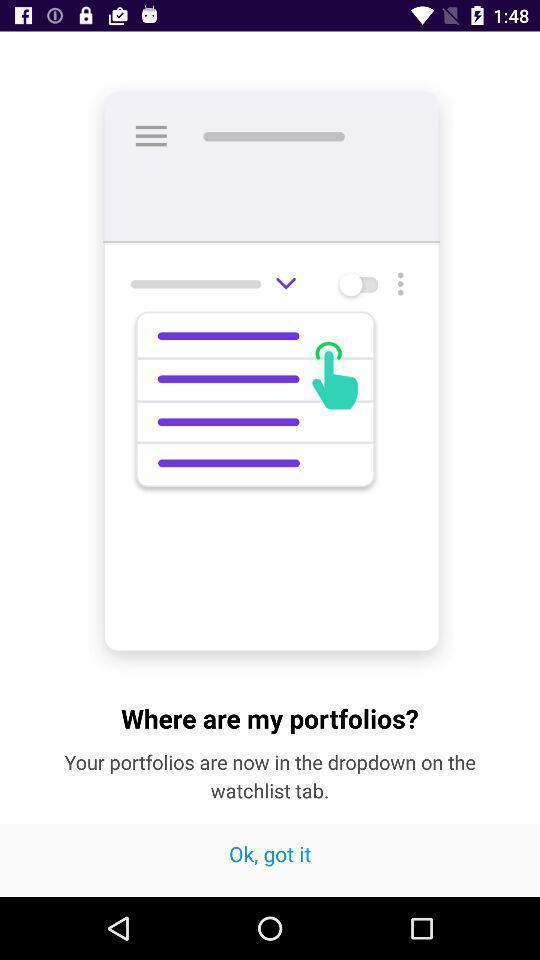Provide a detailed account of this screenshot. Pop up showing a question and answer. 